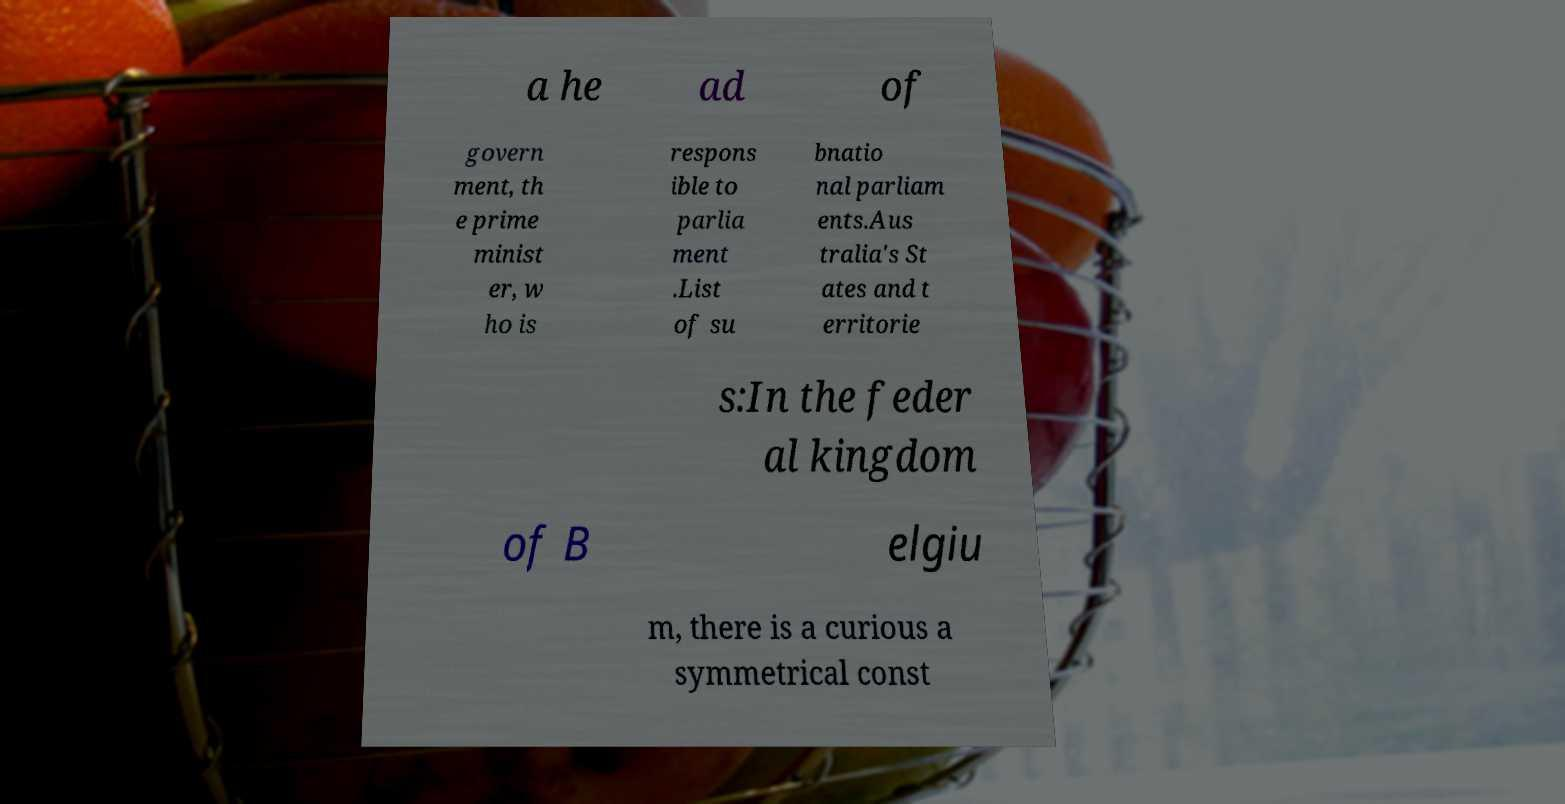For documentation purposes, I need the text within this image transcribed. Could you provide that? a he ad of govern ment, th e prime minist er, w ho is respons ible to parlia ment .List of su bnatio nal parliam ents.Aus tralia's St ates and t erritorie s:In the feder al kingdom of B elgiu m, there is a curious a symmetrical const 